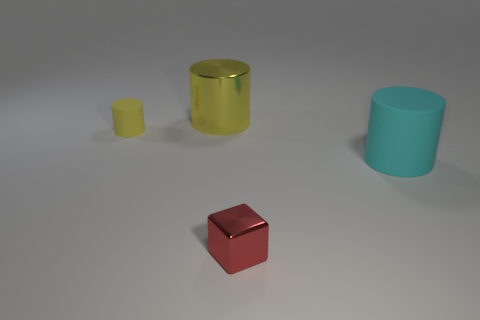Add 2 large matte things. How many objects exist? 6 Subtract all cubes. How many objects are left? 3 Subtract all large cylinders. Subtract all large yellow shiny objects. How many objects are left? 1 Add 1 small rubber cylinders. How many small rubber cylinders are left? 2 Add 1 cyan rubber things. How many cyan rubber things exist? 2 Subtract 0 blue spheres. How many objects are left? 4 